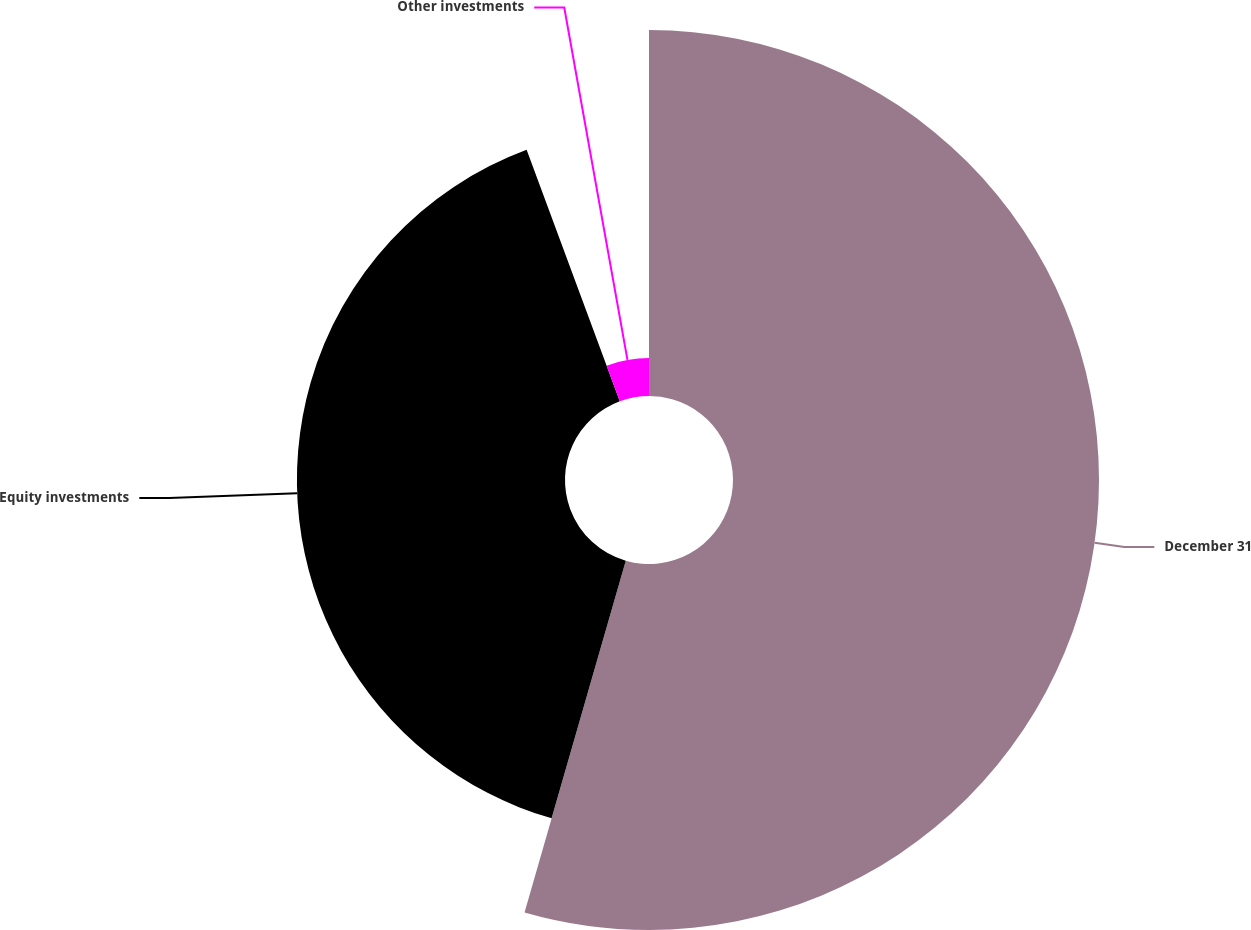<chart> <loc_0><loc_0><loc_500><loc_500><pie_chart><fcel>December 31<fcel>Equity investments<fcel>Other investments<nl><fcel>54.46%<fcel>39.89%<fcel>5.65%<nl></chart> 